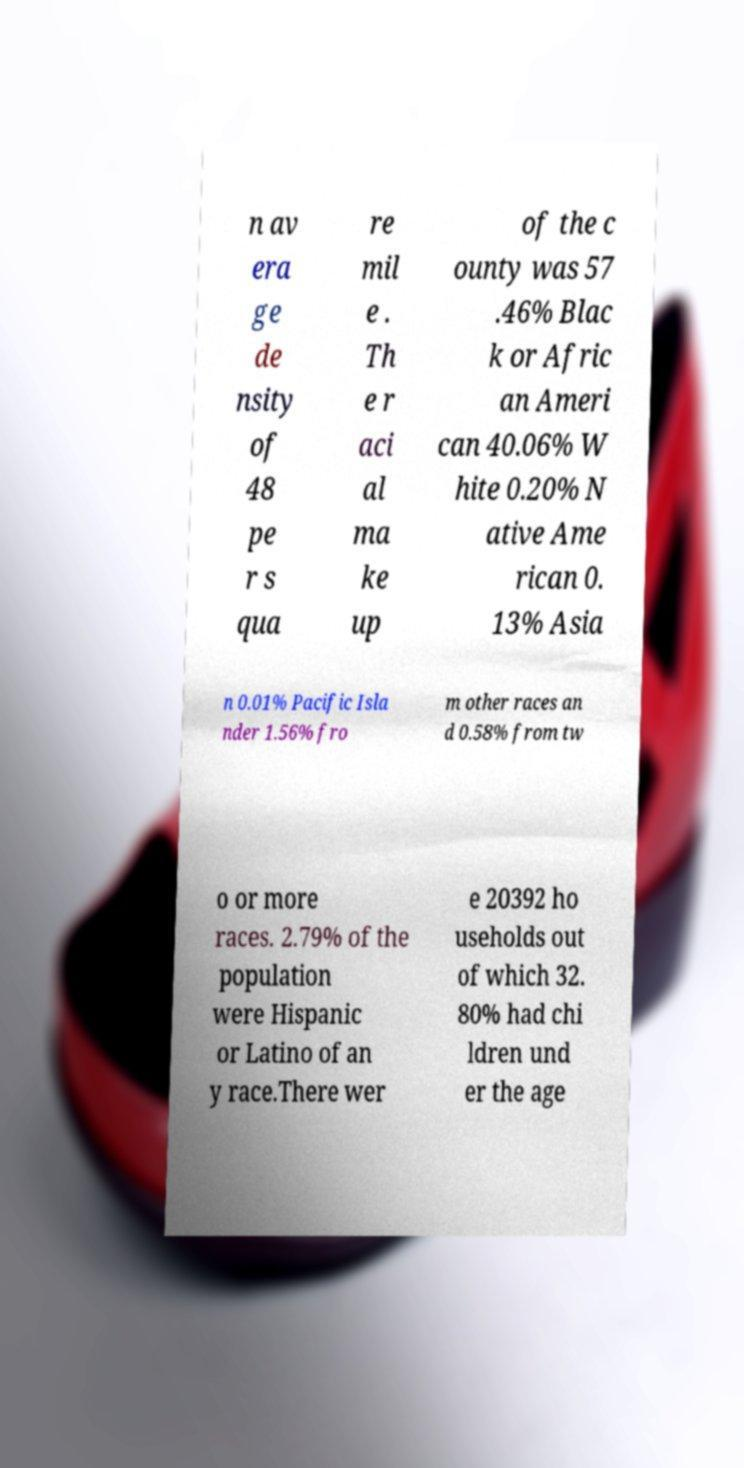What messages or text are displayed in this image? I need them in a readable, typed format. n av era ge de nsity of 48 pe r s qua re mil e . Th e r aci al ma ke up of the c ounty was 57 .46% Blac k or Afric an Ameri can 40.06% W hite 0.20% N ative Ame rican 0. 13% Asia n 0.01% Pacific Isla nder 1.56% fro m other races an d 0.58% from tw o or more races. 2.79% of the population were Hispanic or Latino of an y race.There wer e 20392 ho useholds out of which 32. 80% had chi ldren und er the age 